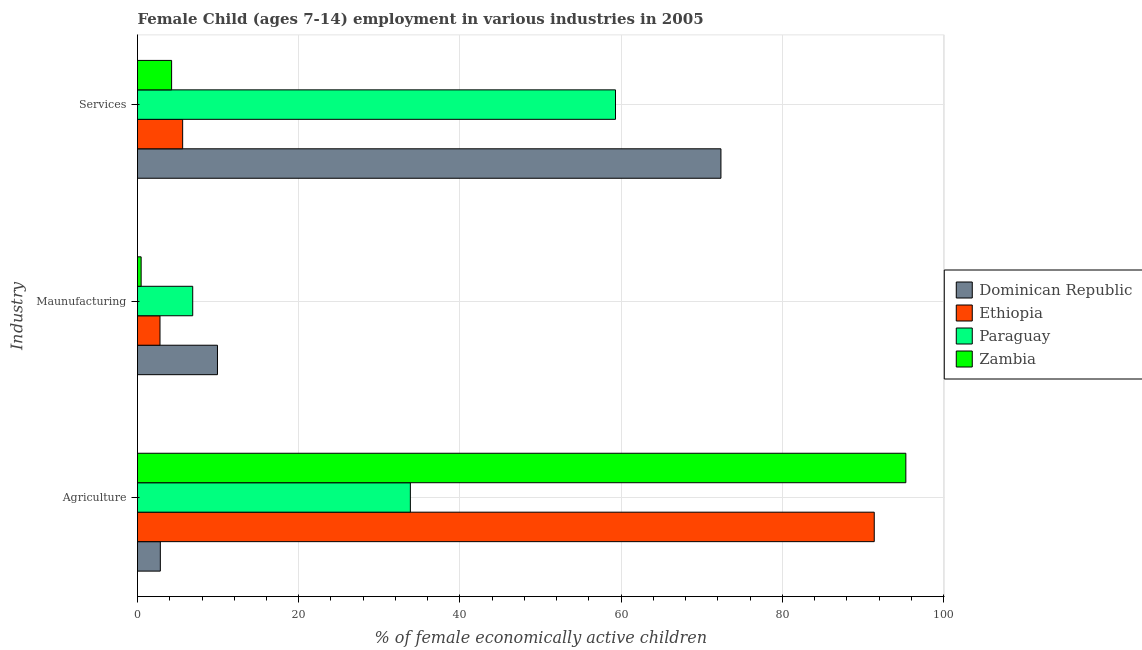How many different coloured bars are there?
Provide a succinct answer. 4. What is the label of the 1st group of bars from the top?
Your answer should be very brief. Services. What is the percentage of economically active children in services in Paraguay?
Ensure brevity in your answer.  59.3. Across all countries, what is the maximum percentage of economically active children in services?
Ensure brevity in your answer.  72.38. Across all countries, what is the minimum percentage of economically active children in agriculture?
Your answer should be compact. 2.83. In which country was the percentage of economically active children in services maximum?
Make the answer very short. Dominican Republic. In which country was the percentage of economically active children in manufacturing minimum?
Your response must be concise. Zambia. What is the total percentage of economically active children in services in the graph?
Your answer should be very brief. 141.51. What is the difference between the percentage of economically active children in agriculture in Dominican Republic and that in Paraguay?
Offer a very short reply. -31.02. What is the difference between the percentage of economically active children in agriculture in Ethiopia and the percentage of economically active children in manufacturing in Dominican Republic?
Offer a very short reply. 81.48. What is the average percentage of economically active children in services per country?
Your response must be concise. 35.38. What is the difference between the percentage of economically active children in services and percentage of economically active children in agriculture in Paraguay?
Your response must be concise. 25.45. In how many countries, is the percentage of economically active children in services greater than 8 %?
Provide a short and direct response. 2. What is the ratio of the percentage of economically active children in manufacturing in Ethiopia to that in Zambia?
Provide a succinct answer. 6.2. Is the difference between the percentage of economically active children in agriculture in Ethiopia and Zambia greater than the difference between the percentage of economically active children in manufacturing in Ethiopia and Zambia?
Offer a terse response. No. What is the difference between the highest and the second highest percentage of economically active children in manufacturing?
Provide a short and direct response. 3.07. What is the difference between the highest and the lowest percentage of economically active children in manufacturing?
Keep it short and to the point. 9.47. Is the sum of the percentage of economically active children in agriculture in Zambia and Ethiopia greater than the maximum percentage of economically active children in manufacturing across all countries?
Your response must be concise. Yes. What does the 4th bar from the top in Maunufacturing represents?
Offer a terse response. Dominican Republic. What does the 4th bar from the bottom in Services represents?
Offer a very short reply. Zambia. Is it the case that in every country, the sum of the percentage of economically active children in agriculture and percentage of economically active children in manufacturing is greater than the percentage of economically active children in services?
Give a very brief answer. No. How many bars are there?
Provide a short and direct response. 12. Are the values on the major ticks of X-axis written in scientific E-notation?
Offer a terse response. No. Does the graph contain grids?
Your answer should be very brief. Yes. How many legend labels are there?
Ensure brevity in your answer.  4. How are the legend labels stacked?
Offer a very short reply. Vertical. What is the title of the graph?
Offer a very short reply. Female Child (ages 7-14) employment in various industries in 2005. What is the label or title of the X-axis?
Ensure brevity in your answer.  % of female economically active children. What is the label or title of the Y-axis?
Provide a short and direct response. Industry. What is the % of female economically active children in Dominican Republic in Agriculture?
Give a very brief answer. 2.83. What is the % of female economically active children in Ethiopia in Agriculture?
Your answer should be very brief. 91.4. What is the % of female economically active children of Paraguay in Agriculture?
Your answer should be very brief. 33.85. What is the % of female economically active children in Zambia in Agriculture?
Make the answer very short. 95.32. What is the % of female economically active children in Dominican Republic in Maunufacturing?
Offer a very short reply. 9.92. What is the % of female economically active children in Ethiopia in Maunufacturing?
Your answer should be compact. 2.79. What is the % of female economically active children in Paraguay in Maunufacturing?
Offer a very short reply. 6.85. What is the % of female economically active children of Zambia in Maunufacturing?
Keep it short and to the point. 0.45. What is the % of female economically active children in Dominican Republic in Services?
Your answer should be compact. 72.38. What is the % of female economically active children in Ethiopia in Services?
Ensure brevity in your answer.  5.6. What is the % of female economically active children of Paraguay in Services?
Make the answer very short. 59.3. What is the % of female economically active children in Zambia in Services?
Offer a terse response. 4.23. Across all Industry, what is the maximum % of female economically active children of Dominican Republic?
Ensure brevity in your answer.  72.38. Across all Industry, what is the maximum % of female economically active children of Ethiopia?
Keep it short and to the point. 91.4. Across all Industry, what is the maximum % of female economically active children of Paraguay?
Offer a very short reply. 59.3. Across all Industry, what is the maximum % of female economically active children in Zambia?
Provide a short and direct response. 95.32. Across all Industry, what is the minimum % of female economically active children of Dominican Republic?
Your answer should be very brief. 2.83. Across all Industry, what is the minimum % of female economically active children of Ethiopia?
Give a very brief answer. 2.79. Across all Industry, what is the minimum % of female economically active children in Paraguay?
Give a very brief answer. 6.85. Across all Industry, what is the minimum % of female economically active children of Zambia?
Keep it short and to the point. 0.45. What is the total % of female economically active children of Dominican Republic in the graph?
Keep it short and to the point. 85.13. What is the total % of female economically active children of Ethiopia in the graph?
Offer a terse response. 99.79. What is the total % of female economically active children in Paraguay in the graph?
Make the answer very short. 100. What is the difference between the % of female economically active children in Dominican Republic in Agriculture and that in Maunufacturing?
Offer a very short reply. -7.09. What is the difference between the % of female economically active children in Ethiopia in Agriculture and that in Maunufacturing?
Provide a short and direct response. 88.61. What is the difference between the % of female economically active children in Paraguay in Agriculture and that in Maunufacturing?
Your answer should be compact. 27. What is the difference between the % of female economically active children of Zambia in Agriculture and that in Maunufacturing?
Offer a very short reply. 94.87. What is the difference between the % of female economically active children in Dominican Republic in Agriculture and that in Services?
Give a very brief answer. -69.55. What is the difference between the % of female economically active children in Ethiopia in Agriculture and that in Services?
Keep it short and to the point. 85.8. What is the difference between the % of female economically active children in Paraguay in Agriculture and that in Services?
Give a very brief answer. -25.45. What is the difference between the % of female economically active children in Zambia in Agriculture and that in Services?
Make the answer very short. 91.09. What is the difference between the % of female economically active children of Dominican Republic in Maunufacturing and that in Services?
Offer a very short reply. -62.46. What is the difference between the % of female economically active children in Ethiopia in Maunufacturing and that in Services?
Make the answer very short. -2.81. What is the difference between the % of female economically active children of Paraguay in Maunufacturing and that in Services?
Keep it short and to the point. -52.45. What is the difference between the % of female economically active children in Zambia in Maunufacturing and that in Services?
Your answer should be compact. -3.78. What is the difference between the % of female economically active children in Dominican Republic in Agriculture and the % of female economically active children in Ethiopia in Maunufacturing?
Give a very brief answer. 0.04. What is the difference between the % of female economically active children in Dominican Republic in Agriculture and the % of female economically active children in Paraguay in Maunufacturing?
Keep it short and to the point. -4.02. What is the difference between the % of female economically active children of Dominican Republic in Agriculture and the % of female economically active children of Zambia in Maunufacturing?
Your answer should be very brief. 2.38. What is the difference between the % of female economically active children in Ethiopia in Agriculture and the % of female economically active children in Paraguay in Maunufacturing?
Make the answer very short. 84.55. What is the difference between the % of female economically active children of Ethiopia in Agriculture and the % of female economically active children of Zambia in Maunufacturing?
Offer a very short reply. 90.95. What is the difference between the % of female economically active children in Paraguay in Agriculture and the % of female economically active children in Zambia in Maunufacturing?
Your response must be concise. 33.4. What is the difference between the % of female economically active children of Dominican Republic in Agriculture and the % of female economically active children of Ethiopia in Services?
Give a very brief answer. -2.77. What is the difference between the % of female economically active children in Dominican Republic in Agriculture and the % of female economically active children in Paraguay in Services?
Your answer should be compact. -56.47. What is the difference between the % of female economically active children in Ethiopia in Agriculture and the % of female economically active children in Paraguay in Services?
Keep it short and to the point. 32.1. What is the difference between the % of female economically active children in Ethiopia in Agriculture and the % of female economically active children in Zambia in Services?
Provide a succinct answer. 87.17. What is the difference between the % of female economically active children of Paraguay in Agriculture and the % of female economically active children of Zambia in Services?
Provide a succinct answer. 29.62. What is the difference between the % of female economically active children in Dominican Republic in Maunufacturing and the % of female economically active children in Ethiopia in Services?
Offer a very short reply. 4.32. What is the difference between the % of female economically active children of Dominican Republic in Maunufacturing and the % of female economically active children of Paraguay in Services?
Offer a very short reply. -49.38. What is the difference between the % of female economically active children in Dominican Republic in Maunufacturing and the % of female economically active children in Zambia in Services?
Your response must be concise. 5.69. What is the difference between the % of female economically active children of Ethiopia in Maunufacturing and the % of female economically active children of Paraguay in Services?
Offer a terse response. -56.51. What is the difference between the % of female economically active children of Ethiopia in Maunufacturing and the % of female economically active children of Zambia in Services?
Provide a short and direct response. -1.44. What is the difference between the % of female economically active children in Paraguay in Maunufacturing and the % of female economically active children in Zambia in Services?
Provide a short and direct response. 2.62. What is the average % of female economically active children in Dominican Republic per Industry?
Your answer should be very brief. 28.38. What is the average % of female economically active children of Ethiopia per Industry?
Offer a very short reply. 33.26. What is the average % of female economically active children in Paraguay per Industry?
Provide a short and direct response. 33.33. What is the average % of female economically active children in Zambia per Industry?
Offer a terse response. 33.33. What is the difference between the % of female economically active children of Dominican Republic and % of female economically active children of Ethiopia in Agriculture?
Your answer should be very brief. -88.57. What is the difference between the % of female economically active children of Dominican Republic and % of female economically active children of Paraguay in Agriculture?
Offer a very short reply. -31.02. What is the difference between the % of female economically active children of Dominican Republic and % of female economically active children of Zambia in Agriculture?
Your answer should be compact. -92.49. What is the difference between the % of female economically active children in Ethiopia and % of female economically active children in Paraguay in Agriculture?
Offer a very short reply. 57.55. What is the difference between the % of female economically active children of Ethiopia and % of female economically active children of Zambia in Agriculture?
Your answer should be compact. -3.92. What is the difference between the % of female economically active children of Paraguay and % of female economically active children of Zambia in Agriculture?
Keep it short and to the point. -61.47. What is the difference between the % of female economically active children in Dominican Republic and % of female economically active children in Ethiopia in Maunufacturing?
Your response must be concise. 7.13. What is the difference between the % of female economically active children in Dominican Republic and % of female economically active children in Paraguay in Maunufacturing?
Make the answer very short. 3.07. What is the difference between the % of female economically active children in Dominican Republic and % of female economically active children in Zambia in Maunufacturing?
Your answer should be very brief. 9.47. What is the difference between the % of female economically active children of Ethiopia and % of female economically active children of Paraguay in Maunufacturing?
Your response must be concise. -4.06. What is the difference between the % of female economically active children of Ethiopia and % of female economically active children of Zambia in Maunufacturing?
Provide a short and direct response. 2.34. What is the difference between the % of female economically active children in Dominican Republic and % of female economically active children in Ethiopia in Services?
Provide a short and direct response. 66.78. What is the difference between the % of female economically active children in Dominican Republic and % of female economically active children in Paraguay in Services?
Provide a succinct answer. 13.08. What is the difference between the % of female economically active children in Dominican Republic and % of female economically active children in Zambia in Services?
Provide a short and direct response. 68.15. What is the difference between the % of female economically active children in Ethiopia and % of female economically active children in Paraguay in Services?
Provide a short and direct response. -53.7. What is the difference between the % of female economically active children of Ethiopia and % of female economically active children of Zambia in Services?
Offer a very short reply. 1.37. What is the difference between the % of female economically active children in Paraguay and % of female economically active children in Zambia in Services?
Give a very brief answer. 55.07. What is the ratio of the % of female economically active children of Dominican Republic in Agriculture to that in Maunufacturing?
Your response must be concise. 0.29. What is the ratio of the % of female economically active children in Ethiopia in Agriculture to that in Maunufacturing?
Your answer should be compact. 32.76. What is the ratio of the % of female economically active children in Paraguay in Agriculture to that in Maunufacturing?
Keep it short and to the point. 4.94. What is the ratio of the % of female economically active children of Zambia in Agriculture to that in Maunufacturing?
Provide a succinct answer. 211.82. What is the ratio of the % of female economically active children in Dominican Republic in Agriculture to that in Services?
Ensure brevity in your answer.  0.04. What is the ratio of the % of female economically active children of Ethiopia in Agriculture to that in Services?
Make the answer very short. 16.32. What is the ratio of the % of female economically active children of Paraguay in Agriculture to that in Services?
Your answer should be compact. 0.57. What is the ratio of the % of female economically active children in Zambia in Agriculture to that in Services?
Provide a short and direct response. 22.53. What is the ratio of the % of female economically active children of Dominican Republic in Maunufacturing to that in Services?
Your answer should be compact. 0.14. What is the ratio of the % of female economically active children in Ethiopia in Maunufacturing to that in Services?
Give a very brief answer. 0.5. What is the ratio of the % of female economically active children of Paraguay in Maunufacturing to that in Services?
Provide a short and direct response. 0.12. What is the ratio of the % of female economically active children of Zambia in Maunufacturing to that in Services?
Offer a terse response. 0.11. What is the difference between the highest and the second highest % of female economically active children of Dominican Republic?
Your answer should be very brief. 62.46. What is the difference between the highest and the second highest % of female economically active children of Ethiopia?
Keep it short and to the point. 85.8. What is the difference between the highest and the second highest % of female economically active children of Paraguay?
Your answer should be compact. 25.45. What is the difference between the highest and the second highest % of female economically active children in Zambia?
Provide a succinct answer. 91.09. What is the difference between the highest and the lowest % of female economically active children in Dominican Republic?
Your response must be concise. 69.55. What is the difference between the highest and the lowest % of female economically active children in Ethiopia?
Make the answer very short. 88.61. What is the difference between the highest and the lowest % of female economically active children of Paraguay?
Provide a succinct answer. 52.45. What is the difference between the highest and the lowest % of female economically active children of Zambia?
Offer a terse response. 94.87. 